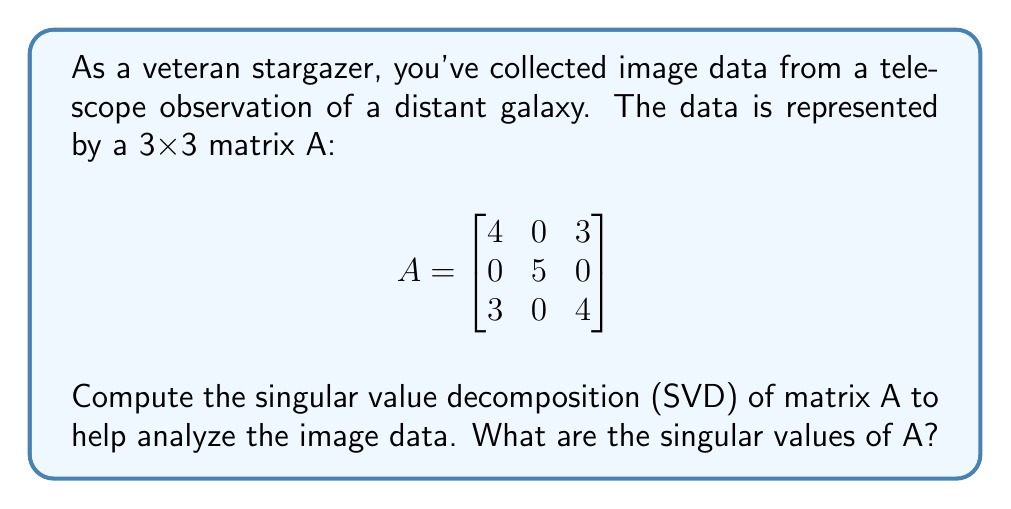What is the answer to this math problem? To find the singular value decomposition of matrix A, we need to follow these steps:

1) First, calculate $A^TA$:

   $$A^TA = \begin{bmatrix}
   4 & 0 & 3\\
   0 & 5 & 0\\
   3 & 0 & 4
   \end{bmatrix}
   \begin{bmatrix}
   4 & 0 & 3\\
   0 & 5 & 0\\
   3 & 0 & 4
   \end{bmatrix}
   = \begin{bmatrix}
   25 & 0 & 24\\
   0 & 25 & 0\\
   24 & 0 & 25
   \end{bmatrix}$$

2) Find the eigenvalues of $A^TA$ by solving the characteristic equation:
   
   $\det(A^TA - \lambda I) = 0$

   $\begin{vmatrix}
   25-\lambda & 0 & 24\\
   0 & 25-\lambda & 0\\
   24 & 0 & 25-\lambda
   \end{vmatrix} = 0$

   $(25-\lambda)[(25-\lambda)^2 - 576] = 0$

   $(25-\lambda)(25-\lambda-24)(25-\lambda+24) = 0$

   $(\lambda-25)(\lambda-49)(\lambda-1) = 0$

3) The eigenvalues are $\lambda_1 = 49$, $\lambda_2 = 25$, and $\lambda_3 = 1$

4) The singular values are the square roots of these eigenvalues:

   $\sigma_1 = \sqrt{49} = 7$
   $\sigma_2 = \sqrt{25} = 5$
   $\sigma_3 = \sqrt{1} = 1$

Therefore, the singular values of A are 7, 5, and 1.
Answer: $\sigma_1 = 7$, $\sigma_2 = 5$, $\sigma_3 = 1$ 